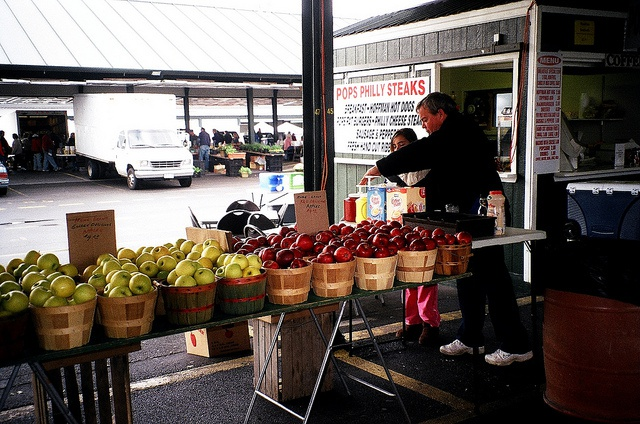Describe the objects in this image and their specific colors. I can see people in white, black, maroon, gray, and darkgray tones, truck in white, black, darkgray, and gray tones, bowl in white, tan, brown, and gray tones, apple in white, maroon, black, and brown tones, and truck in white, black, gray, and maroon tones in this image. 